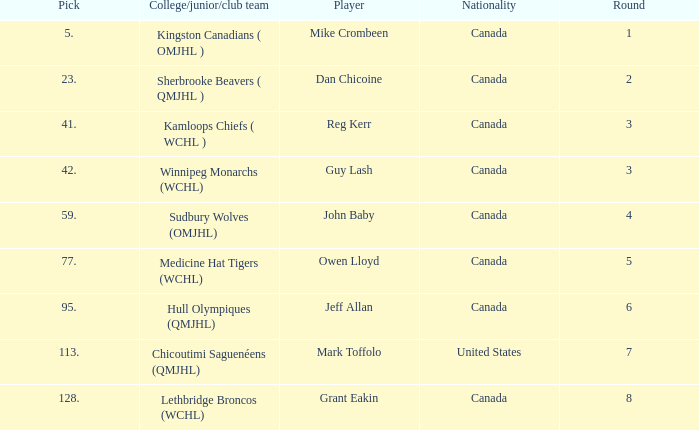Could you help me parse every detail presented in this table? {'header': ['Pick', 'College/junior/club team', 'Player', 'Nationality', 'Round'], 'rows': [['5.', 'Kingston Canadians ( OMJHL )', 'Mike Crombeen', 'Canada', '1'], ['23.', 'Sherbrooke Beavers ( QMJHL )', 'Dan Chicoine', 'Canada', '2'], ['41.', 'Kamloops Chiefs ( WCHL )', 'Reg Kerr', 'Canada', '3'], ['42.', 'Winnipeg Monarchs (WCHL)', 'Guy Lash', 'Canada', '3'], ['59.', 'Sudbury Wolves (OMJHL)', 'John Baby', 'Canada', '4'], ['77.', 'Medicine Hat Tigers (WCHL)', 'Owen Lloyd', 'Canada', '5'], ['95.', 'Hull Olympiques (QMJHL)', 'Jeff Allan', 'Canada', '6'], ['113.', 'Chicoutimi Saguenéens (QMJHL)', 'Mark Toffolo', 'United States', '7'], ['128.', 'Lethbridge Broncos (WCHL)', 'Grant Eakin', 'Canada', '8']]} Which College/junior/club team has a Round of 2? Sherbrooke Beavers ( QMJHL ). 